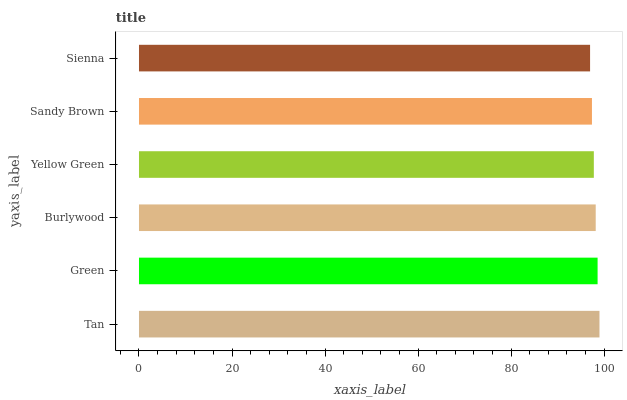Is Sienna the minimum?
Answer yes or no. Yes. Is Tan the maximum?
Answer yes or no. Yes. Is Green the minimum?
Answer yes or no. No. Is Green the maximum?
Answer yes or no. No. Is Tan greater than Green?
Answer yes or no. Yes. Is Green less than Tan?
Answer yes or no. Yes. Is Green greater than Tan?
Answer yes or no. No. Is Tan less than Green?
Answer yes or no. No. Is Burlywood the high median?
Answer yes or no. Yes. Is Yellow Green the low median?
Answer yes or no. Yes. Is Sienna the high median?
Answer yes or no. No. Is Tan the low median?
Answer yes or no. No. 